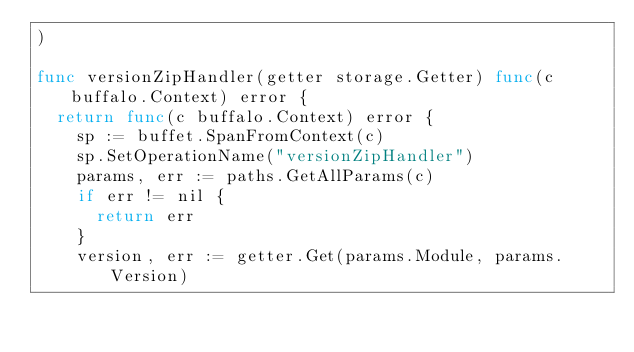<code> <loc_0><loc_0><loc_500><loc_500><_Go_>)

func versionZipHandler(getter storage.Getter) func(c buffalo.Context) error {
	return func(c buffalo.Context) error {
		sp := buffet.SpanFromContext(c)
		sp.SetOperationName("versionZipHandler")
		params, err := paths.GetAllParams(c)
		if err != nil {
			return err
		}
		version, err := getter.Get(params.Module, params.Version)</code> 